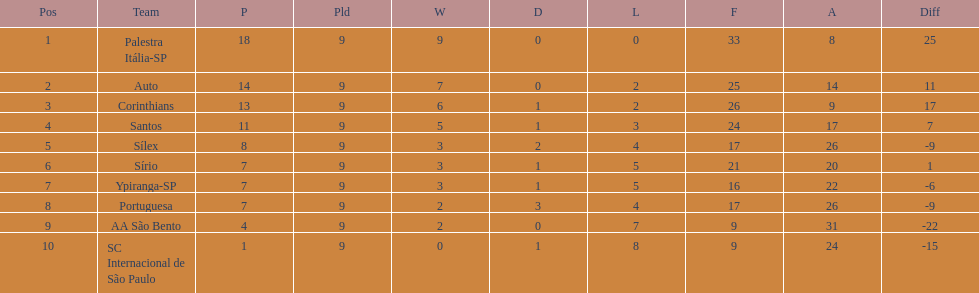In 1926 brazilian football, how many teams scored above 10 points in the season? 4. 